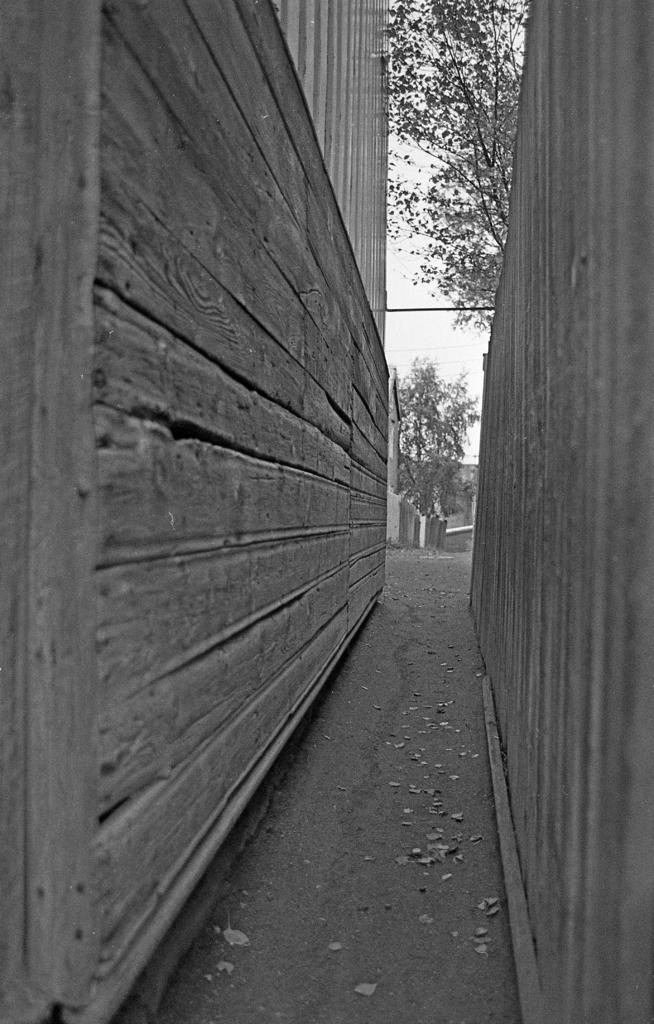What type of vegetation can be seen on the ground in the image? There are leaves on the ground in the image. What type of structures are visible in the image? There are walls visible in the image. What type of plants are present in the image? There are trees in the image. What can be seen in the background of the image? The sky is visible in the background of the image. How many bananas can be seen hanging from the trees in the image? There are no bananas present in the image; it features leaves, walls, trees, and the sky. What type of worm can be seen in the image? There are no worms or any other type of creature visible in the image. 